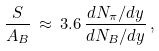<formula> <loc_0><loc_0><loc_500><loc_500>\frac { S } { A _ { B } } \, \approx \, 3 . 6 \, \frac { d N _ { \pi } / d y } { d N _ { B } / d y } \, ,</formula> 